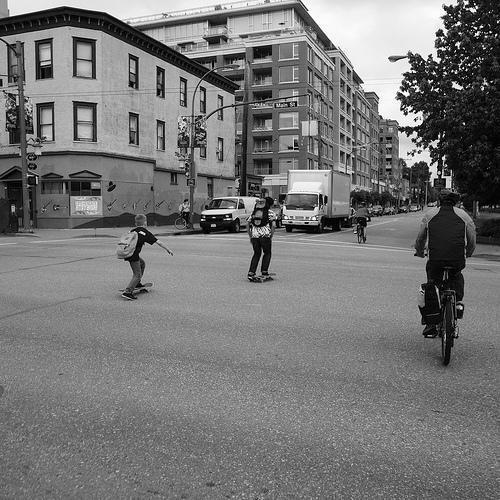How many skateboarders are in the picture?
Give a very brief answer. 2. How many people ride in bicycle?
Give a very brief answer. 2. 